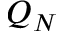Convert formula to latex. <formula><loc_0><loc_0><loc_500><loc_500>Q _ { N }</formula> 